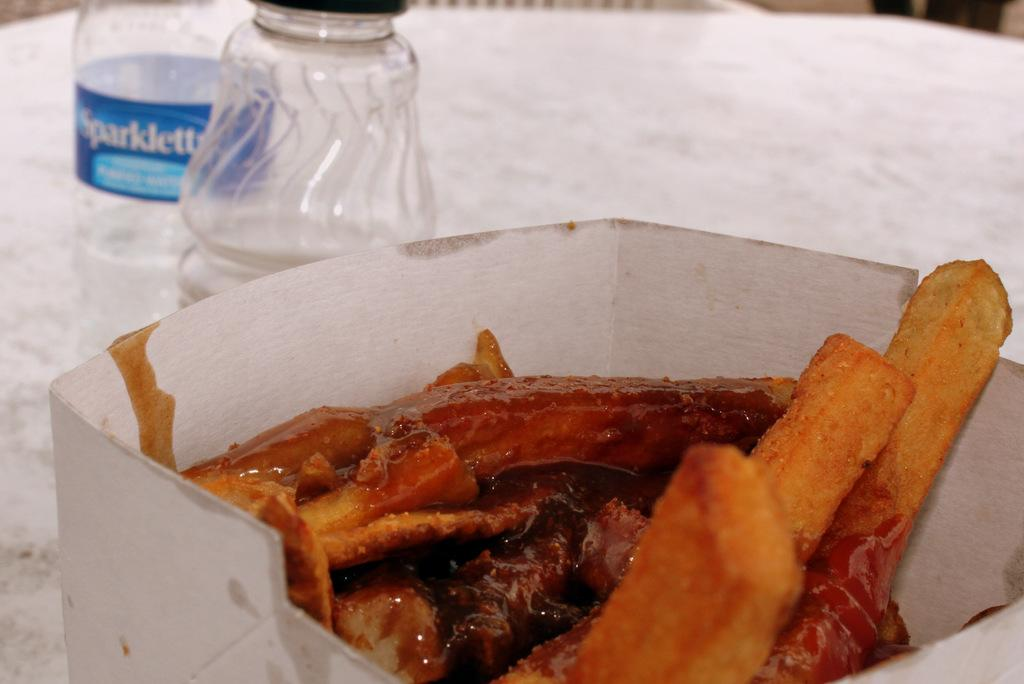<image>
Provide a brief description of the given image. A carton of food containing fries and a bottle of water labelled:"Sparklett.." 